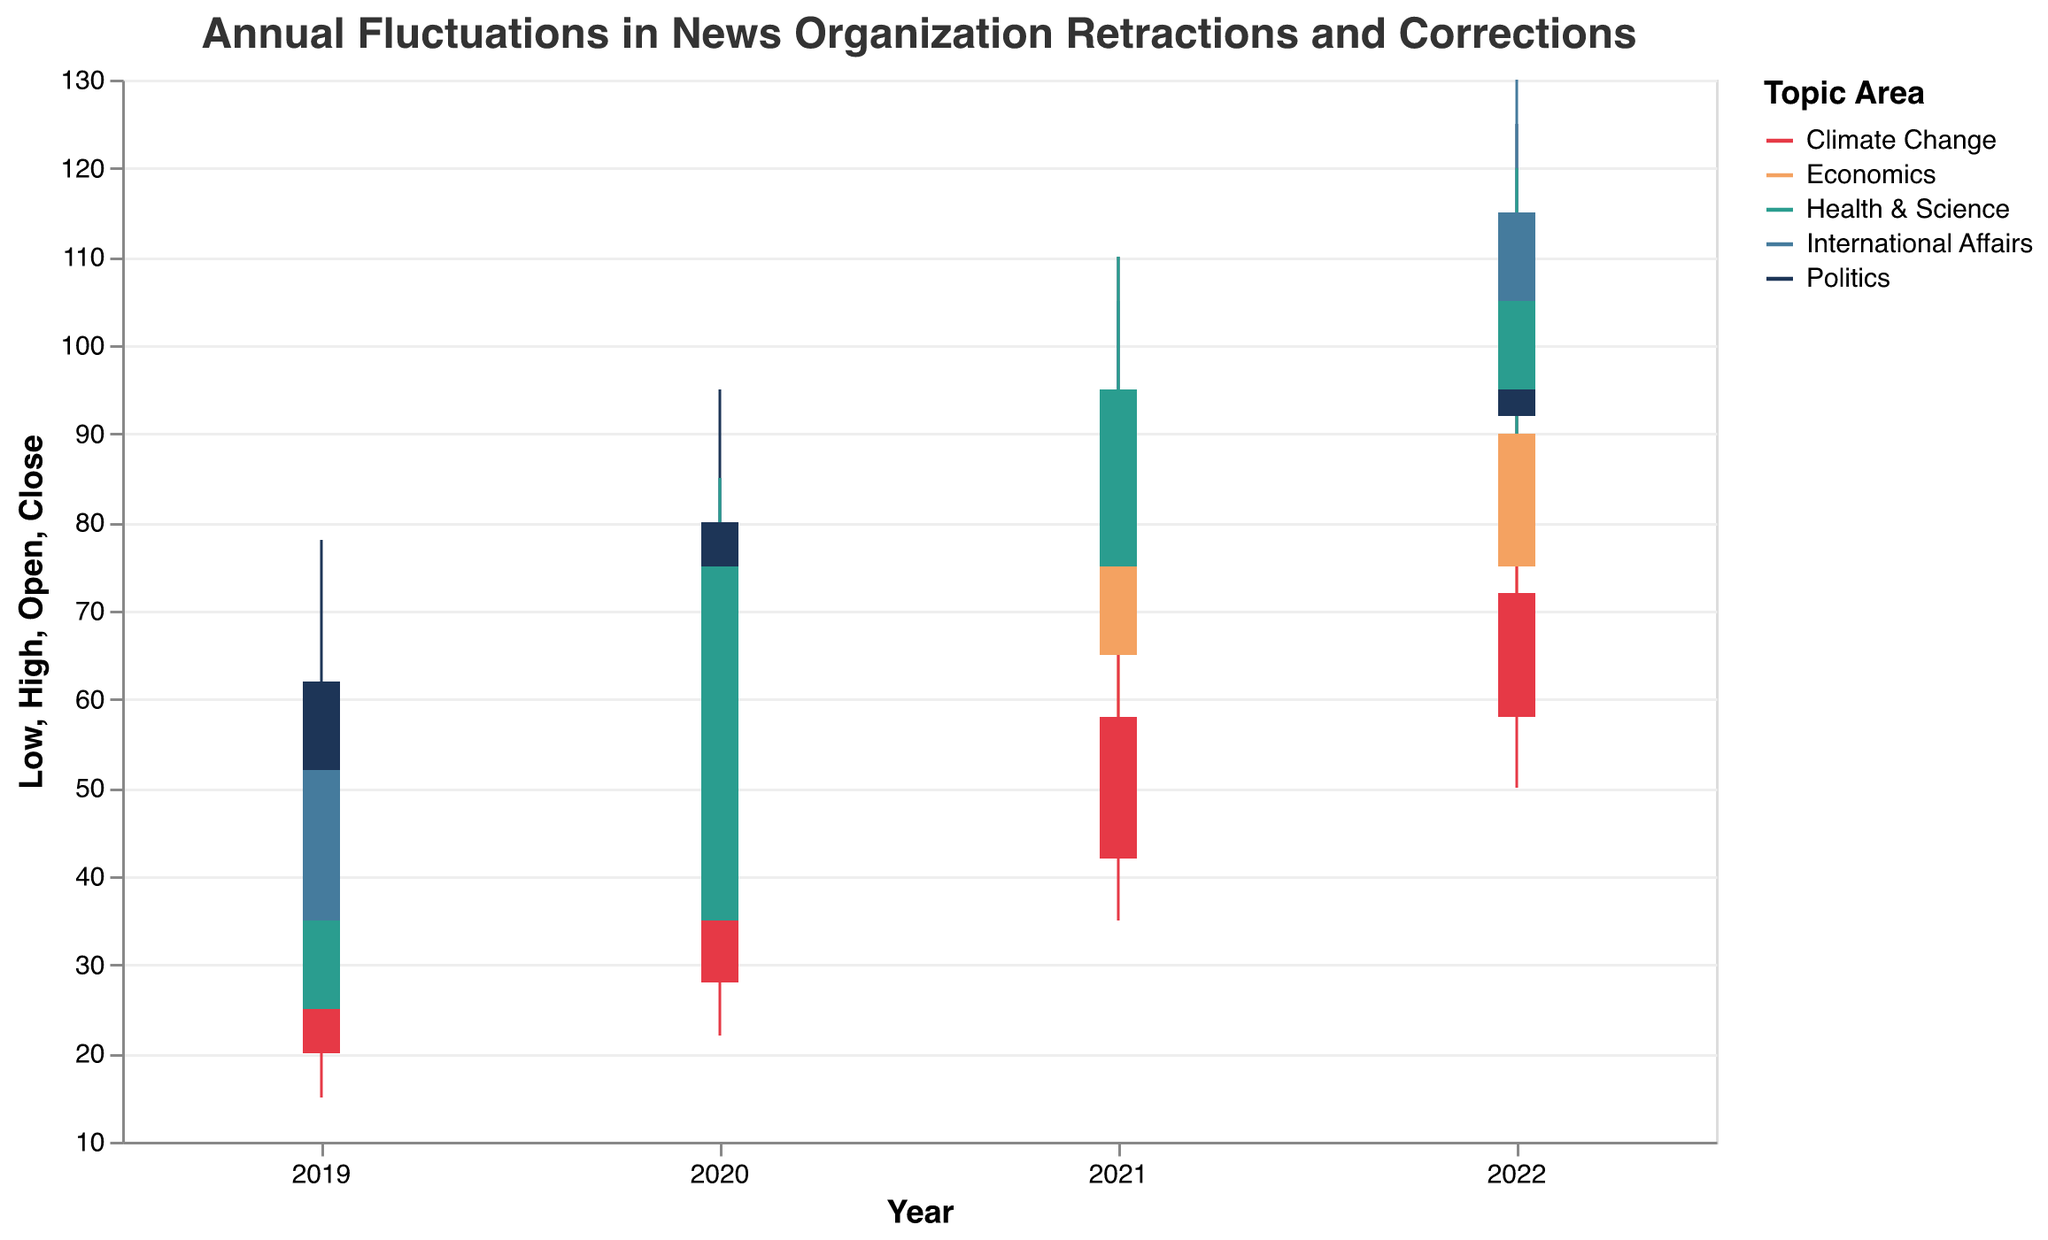What is the title of the chart? The title is typically located at the top of the chart and describes what the chart is about. The title is "Annual Fluctuations in News Organization Retractions and Corrections".
Answer: Annual Fluctuations in News Organization Retractions and Corrections What colors represent the different topic areas? The colors are shown in the legend, each corresponding to a specific topic area. Politics is red, Economics is orange, Climate Change is green, International Affairs is blue, and Health & Science is navy blue.
Answer: Red, Orange, Green, Blue, Navy Blue Which year had the highest closing value for Politics? By examining the OHLC bars for Politics over the years, we can see the closing values. In 2022, Politics had the highest closing value of 105.
Answer: 2022 Which topic area saw the largest high value in 2021? Checking the High values for each topic in 2021, International Affairs had a high of 105, Politics had 110, Economics had 88, Climate Change had 65, and Health & Science had 110. Politics and Health & Science both had the largest high values of 110.
Answer: Politics and Health & Science How did the number of retractions and corrections for Climate Change change from 2019 to 2022? Referencing the OHLC values for Climate Change from 2019 to 2022, in 2019 the Close value was 28, and in 2022 it was 72. The count increased by 44 units.
Answer: Increased by 44 What was the low value for Health & Science in 2020? By looking at the 2020 OHLC bar for Health & Science, the low value was 30.
Answer: 30 Did the number of retractions and corrections in Economics consistently increase every year from 2019 to 2022? By examining the OHLC bars for Economics from 2019 to 2022, we observe the Close values are 48, 65, 75, and 90 respectively, indicating a consistent increase each year.
Answer: Yes Which topic area had the highest volatility (difference between high and low values) in 2020? To determine volatility, subtract the Low value from the High value for each topic in 2020. Politics: 95-55=40, Economics: 70-40=30, Climate Change: 50-22=28, International Affairs: 85-45=40, Health & Science: 85-30=55. Health & Science had the highest volatility with 55.
Answer: Health & Science What is the trend in the number of retractions and corrections for International Affairs from 2019 to 2022? Based on the Close values from 2019 to 2022 for International Affairs, which are 52, 75, 95, and 115 respectively, there is an increasing trend.
Answer: Increasing 